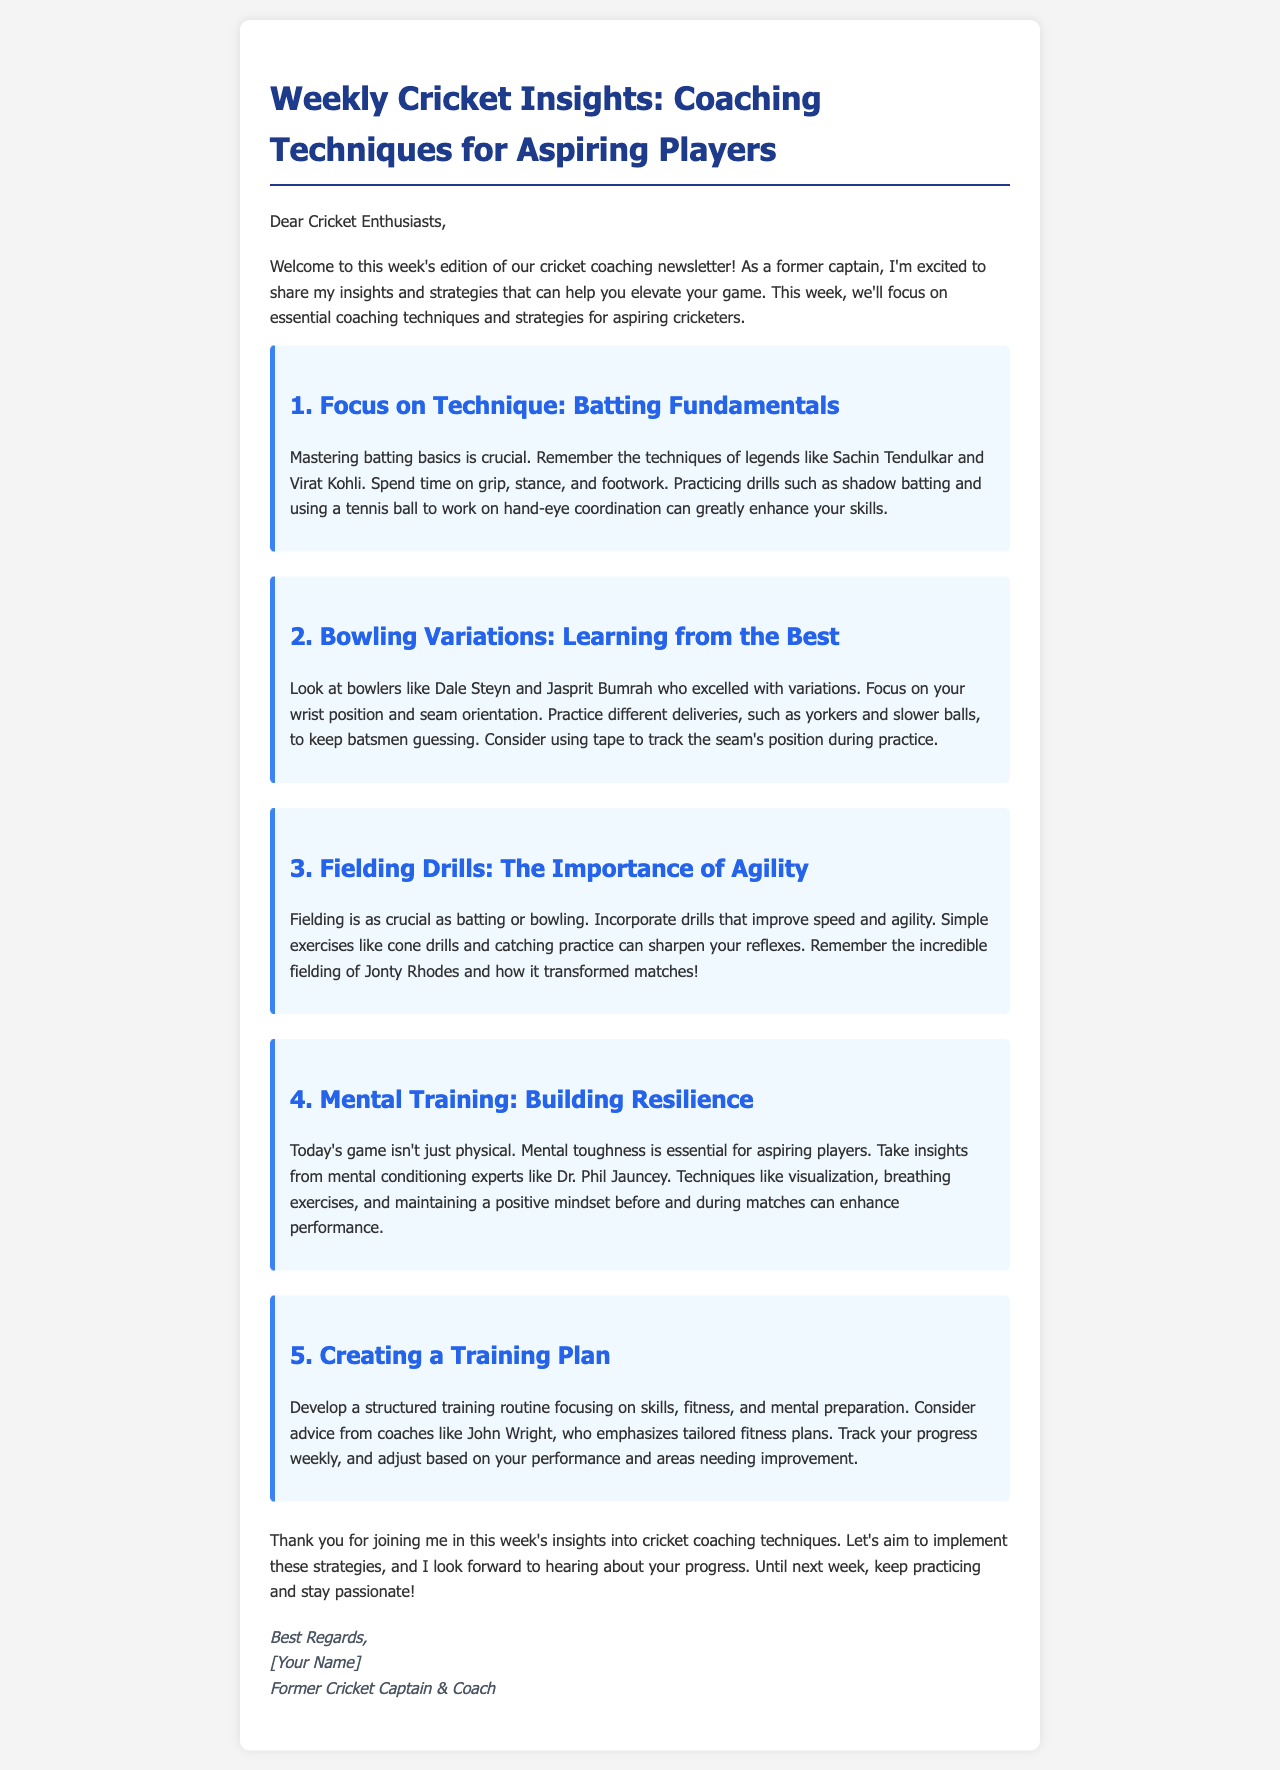What is the title of the newsletter? The title of the newsletter is provided in the opening section of the document.
Answer: Weekly Cricket Insights: Coaching Techniques for Aspiring Players Who is the intended audience of the email? The introduction clearly addresses the target group for the newsletter.
Answer: Cricket Enthusiasts What is the first coaching technique discussed? The first section outlines the focus of the coaching technique that will be discussed.
Answer: Batting Fundamentals Which cricketer is mentioned as an example for fielding excellence? The document mentions a legendary cricketer known for his fielding skills in the section on fielding drills.
Answer: Jonty Rhodes What mental training aspect is emphasized in the newsletter? The section on mental training specifically highlights the importance of a certain quality for players.
Answer: Resilience How many coaching techniques are outlined in the newsletter? The newsletter has a list that clearly indicates the number of techniques provided for aspiring players.
Answer: Five Who is referenced as a mental conditioning expert? The mental training section cites an expert known for their contributions to mental conditioning.
Answer: Dr. Phil Jauncey What is encouraged at the end of the newsletter? The closing remarks motivate readers on how to proceed after reading the insights.
Answer: Keep practicing and stay passionate! 